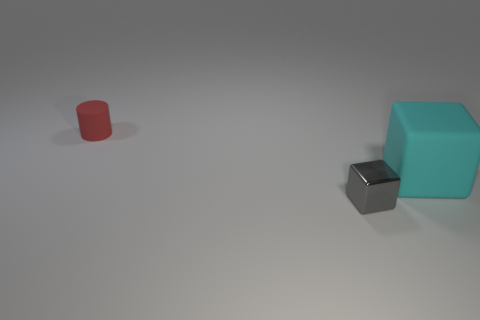Subtract all purple cubes. Subtract all brown cylinders. How many cubes are left? 2 Add 2 small matte balls. How many objects exist? 5 Subtract all blocks. How many objects are left? 1 Subtract all small yellow cylinders. Subtract all red cylinders. How many objects are left? 2 Add 3 gray shiny cubes. How many gray shiny cubes are left? 4 Add 1 tiny gray objects. How many tiny gray objects exist? 2 Subtract 0 brown spheres. How many objects are left? 3 